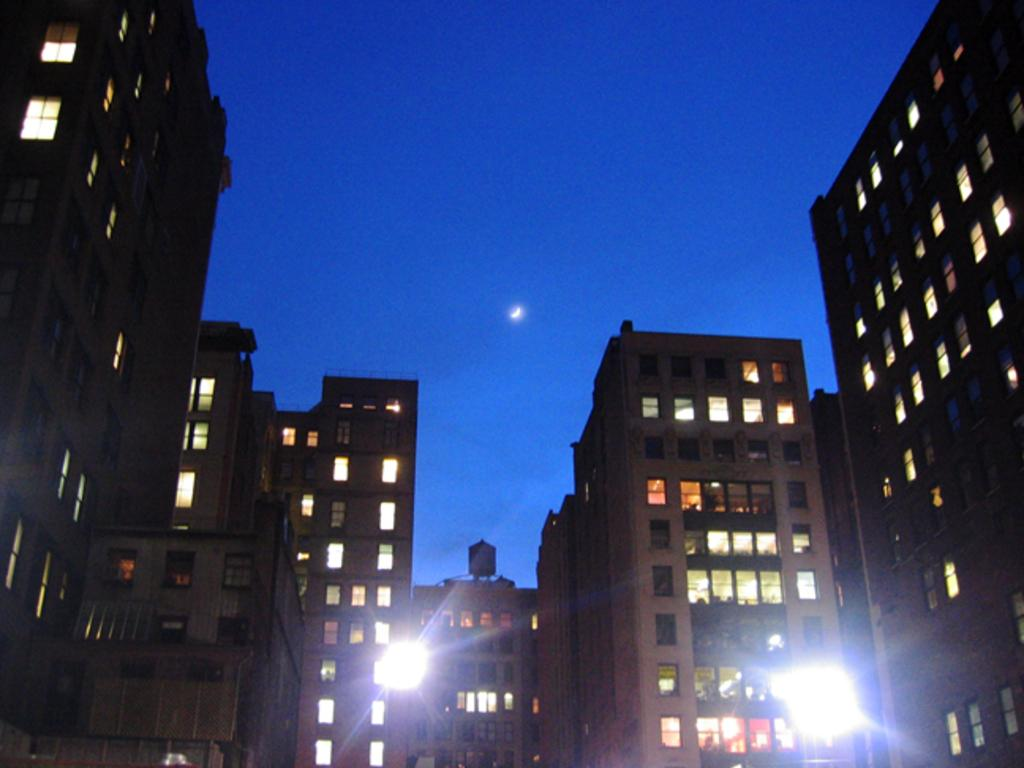What type of structures are present in the image? There are buildings in the image. What architectural feature can be seen on the buildings? There are windows visible in the image. What type of street furniture is present in the image? There are light-poles in the image. What is the color of the sky in the image? The sky is blue in the image. Can you see a ray of sunshine hitting the bed in the image? There is no bed present in the image, and therefore no ray of sunshine hitting it. What type of list is visible on the buildings in the image? There is no list visible on the buildings in the image. 